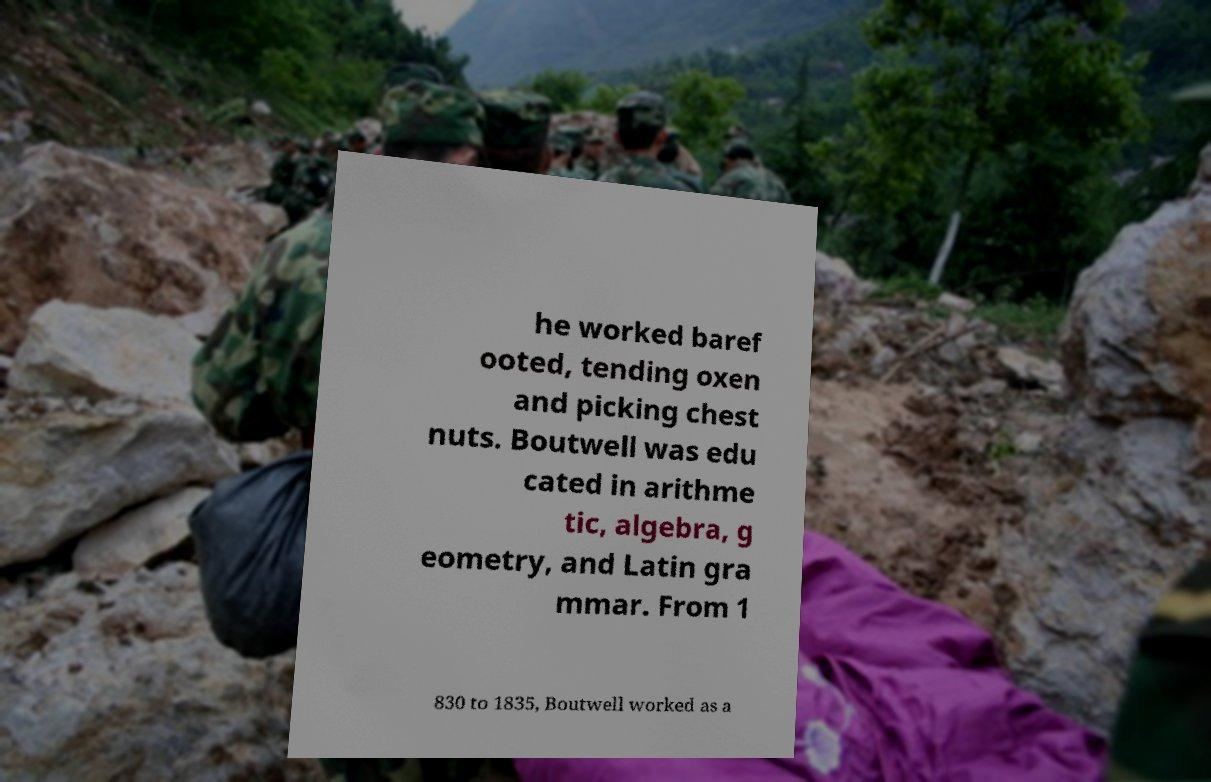Can you read and provide the text displayed in the image?This photo seems to have some interesting text. Can you extract and type it out for me? he worked baref ooted, tending oxen and picking chest nuts. Boutwell was edu cated in arithme tic, algebra, g eometry, and Latin gra mmar. From 1 830 to 1835, Boutwell worked as a 